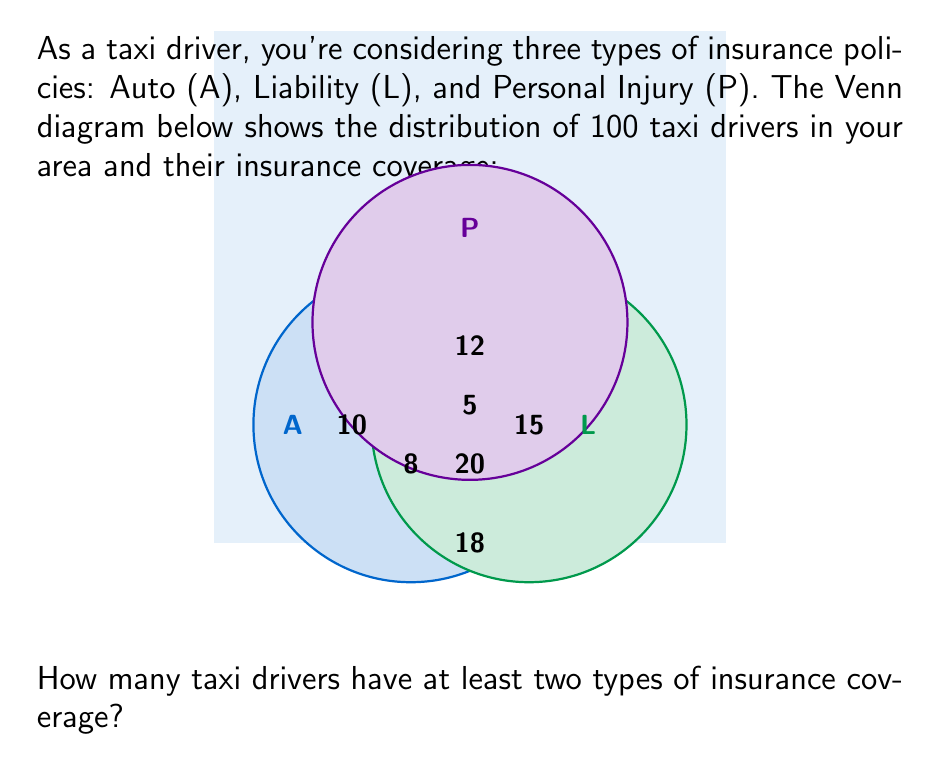Can you answer this question? Let's approach this step-by-step:

1) First, we need to identify the regions in the Venn diagram that represent drivers with at least two types of insurance coverage:

   - The region where A and L overlap: 8 drivers
   - The region where A and P overlap: 12 drivers
   - The region where L and P overlap: 20 drivers
   - The region where all three (A, L, and P) overlap: 5 drivers

2) Now, we need to be careful not to double-count the drivers in the center region (where all three circles overlap). This region is already included in each of the two-circle overlap regions.

3) So, we can calculate the total number of drivers with at least two types of coverage by adding the numbers in the two-circle overlap regions:

   $8 + 12 + 20 = 40$

4) This sum already includes the drivers in the center region (with all three types of coverage), so we don't need to add them separately.

Therefore, 40 taxi drivers have at least two types of insurance coverage.
Answer: 40 drivers 